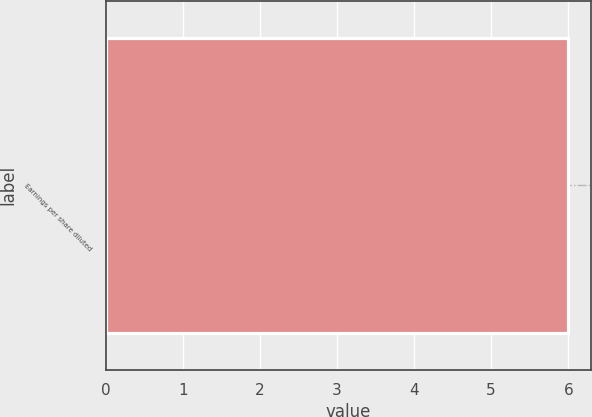<chart> <loc_0><loc_0><loc_500><loc_500><bar_chart><fcel>Earnings per share diluted<nl><fcel>6<nl></chart> 